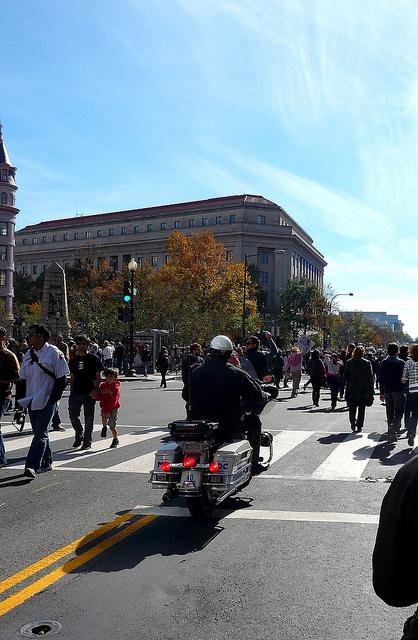What time of year was this picture taken?
Be succinct. Fall. Is that a cop on the motorcycle?
Quick response, please. Yes. Is there snow on the ground?
Short answer required. No. Is it sunny?
Short answer required. Yes. 